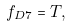<formula> <loc_0><loc_0><loc_500><loc_500>f _ { D 7 } = T ,</formula> 